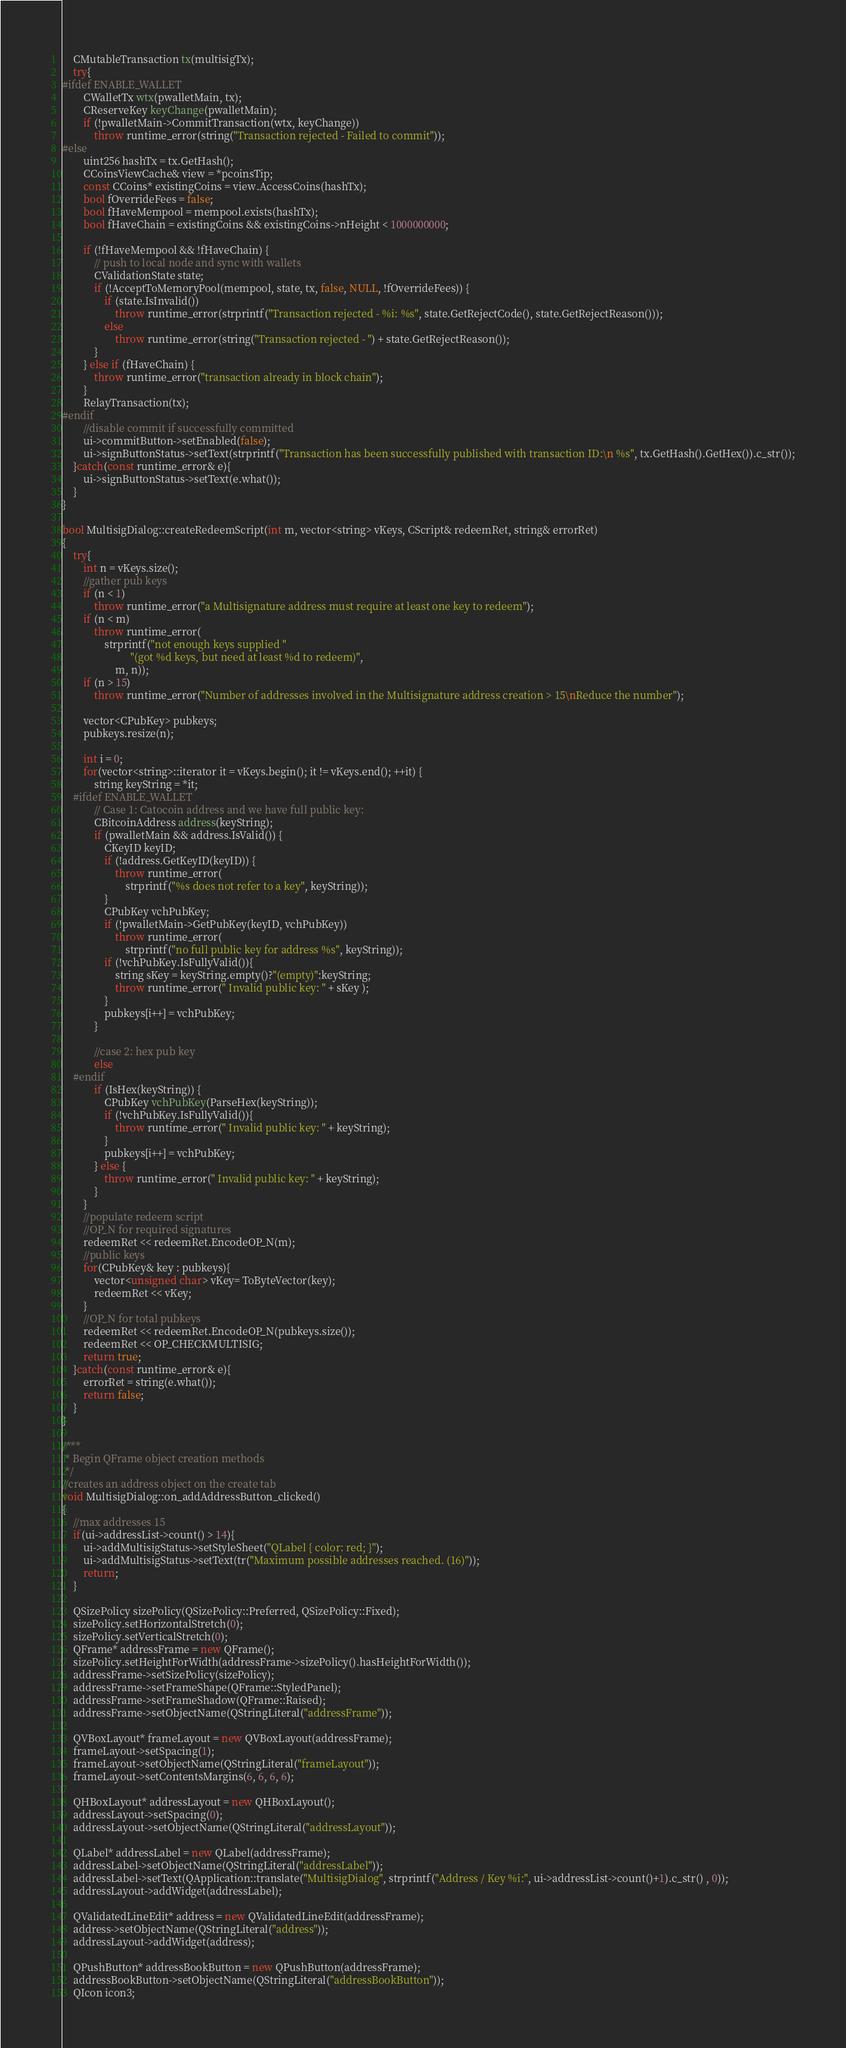<code> <loc_0><loc_0><loc_500><loc_500><_C++_>    CMutableTransaction tx(multisigTx);
    try{
#ifdef ENABLE_WALLET
        CWalletTx wtx(pwalletMain, tx);
        CReserveKey keyChange(pwalletMain);
        if (!pwalletMain->CommitTransaction(wtx, keyChange))
            throw runtime_error(string("Transaction rejected - Failed to commit"));
#else
        uint256 hashTx = tx.GetHash();
        CCoinsViewCache& view = *pcoinsTip;
        const CCoins* existingCoins = view.AccessCoins(hashTx);
        bool fOverrideFees = false;
        bool fHaveMempool = mempool.exists(hashTx);
        bool fHaveChain = existingCoins && existingCoins->nHeight < 1000000000;

        if (!fHaveMempool && !fHaveChain) {
            // push to local node and sync with wallets
            CValidationState state;
            if (!AcceptToMemoryPool(mempool, state, tx, false, NULL, !fOverrideFees)) {
                if (state.IsInvalid())
                    throw runtime_error(strprintf("Transaction rejected - %i: %s", state.GetRejectCode(), state.GetRejectReason()));
                else
                    throw runtime_error(string("Transaction rejected - ") + state.GetRejectReason());
            }
        } else if (fHaveChain) {
            throw runtime_error("transaction already in block chain");
        }
        RelayTransaction(tx);
#endif
        //disable commit if successfully committed
        ui->commitButton->setEnabled(false);
        ui->signButtonStatus->setText(strprintf("Transaction has been successfully published with transaction ID:\n %s", tx.GetHash().GetHex()).c_str());
    }catch(const runtime_error& e){
        ui->signButtonStatus->setText(e.what());
    }
}

bool MultisigDialog::createRedeemScript(int m, vector<string> vKeys, CScript& redeemRet, string& errorRet)
{
    try{
        int n = vKeys.size();
        //gather pub keys
        if (n < 1)
            throw runtime_error("a Multisignature address must require at least one key to redeem");
        if (n < m)
            throw runtime_error(
                strprintf("not enough keys supplied "
                          "(got %d keys, but need at least %d to redeem)",
                    m, n));
        if (n > 15)
            throw runtime_error("Number of addresses involved in the Multisignature address creation > 15\nReduce the number");

        vector<CPubKey> pubkeys;
        pubkeys.resize(n);

        int i = 0;
        for(vector<string>::iterator it = vKeys.begin(); it != vKeys.end(); ++it) {
            string keyString = *it;
    #ifdef ENABLE_WALLET
            // Case 1: Catocoin address and we have full public key:
            CBitcoinAddress address(keyString);
            if (pwalletMain && address.IsValid()) {
                CKeyID keyID;
                if (!address.GetKeyID(keyID)) {
                    throw runtime_error(
                        strprintf("%s does not refer to a key", keyString));
                }
                CPubKey vchPubKey;
                if (!pwalletMain->GetPubKey(keyID, vchPubKey))
                    throw runtime_error(
                        strprintf("no full public key for address %s", keyString));
                if (!vchPubKey.IsFullyValid()){
                    string sKey = keyString.empty()?"(empty)":keyString;
                    throw runtime_error(" Invalid public key: " + sKey );
                }
                pubkeys[i++] = vchPubKey;
            }

            //case 2: hex pub key
            else
    #endif
            if (IsHex(keyString)) {
                CPubKey vchPubKey(ParseHex(keyString));
                if (!vchPubKey.IsFullyValid()){
                    throw runtime_error(" Invalid public key: " + keyString);
                }
                pubkeys[i++] = vchPubKey;
            } else {
                throw runtime_error(" Invalid public key: " + keyString);
            }
        }
        //populate redeem script
        //OP_N for required signatures
        redeemRet << redeemRet.EncodeOP_N(m);
        //public keys
        for(CPubKey& key : pubkeys){
            vector<unsigned char> vKey= ToByteVector(key);
            redeemRet << vKey;
        }
        //OP_N for total pubkeys
        redeemRet << redeemRet.EncodeOP_N(pubkeys.size());
        redeemRet << OP_CHECKMULTISIG;
        return true;
    }catch(const runtime_error& e){
        errorRet = string(e.what());
        return false;
    }
}

/***
 * Begin QFrame object creation methods
 */
//creates an address object on the create tab
void MultisigDialog::on_addAddressButton_clicked()
{
    //max addresses 15
    if(ui->addressList->count() > 14){
        ui->addMultisigStatus->setStyleSheet("QLabel { color: red; }");
        ui->addMultisigStatus->setText(tr("Maximum possible addresses reached. (16)"));
        return;
    }

    QSizePolicy sizePolicy(QSizePolicy::Preferred, QSizePolicy::Fixed);
    sizePolicy.setHorizontalStretch(0);
    sizePolicy.setVerticalStretch(0);
    QFrame* addressFrame = new QFrame();
    sizePolicy.setHeightForWidth(addressFrame->sizePolicy().hasHeightForWidth());
    addressFrame->setSizePolicy(sizePolicy);
    addressFrame->setFrameShape(QFrame::StyledPanel);
    addressFrame->setFrameShadow(QFrame::Raised);
    addressFrame->setObjectName(QStringLiteral("addressFrame"));

    QVBoxLayout* frameLayout = new QVBoxLayout(addressFrame);
    frameLayout->setSpacing(1);
    frameLayout->setObjectName(QStringLiteral("frameLayout"));
    frameLayout->setContentsMargins(6, 6, 6, 6);

    QHBoxLayout* addressLayout = new QHBoxLayout();
    addressLayout->setSpacing(0);
    addressLayout->setObjectName(QStringLiteral("addressLayout"));

    QLabel* addressLabel = new QLabel(addressFrame);
    addressLabel->setObjectName(QStringLiteral("addressLabel"));
    addressLabel->setText(QApplication::translate("MultisigDialog", strprintf("Address / Key %i:", ui->addressList->count()+1).c_str() , 0));
    addressLayout->addWidget(addressLabel);

    QValidatedLineEdit* address = new QValidatedLineEdit(addressFrame);
    address->setObjectName(QStringLiteral("address"));
    addressLayout->addWidget(address);

    QPushButton* addressBookButton = new QPushButton(addressFrame);
    addressBookButton->setObjectName(QStringLiteral("addressBookButton"));
    QIcon icon3;</code> 